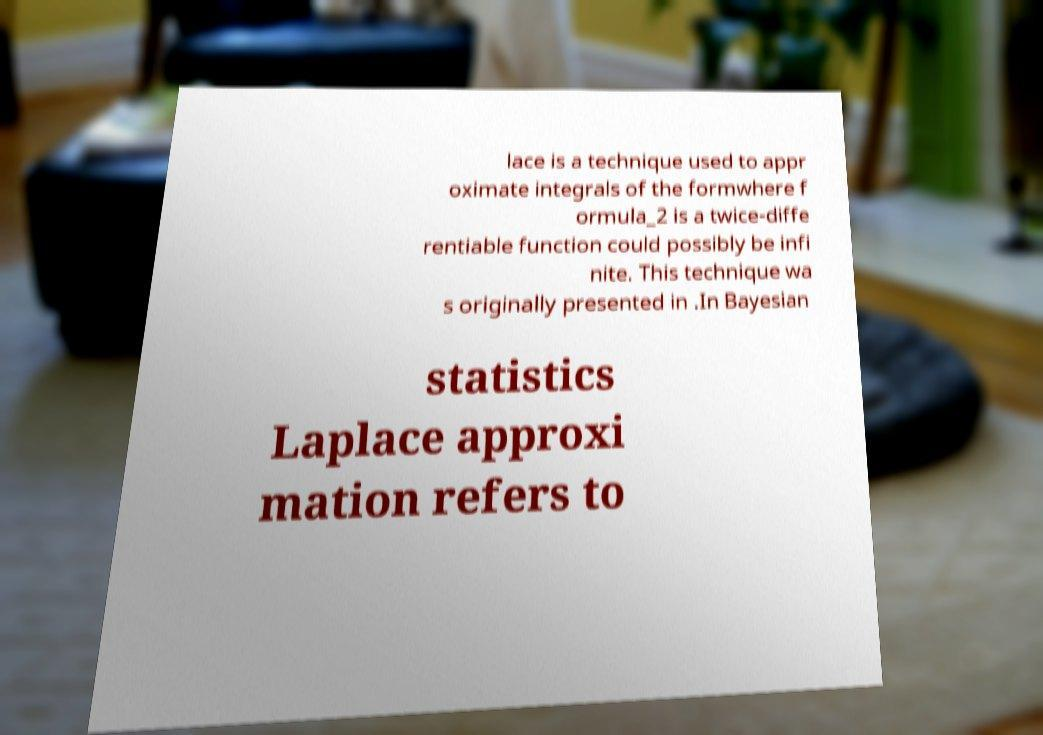Could you extract and type out the text from this image? lace is a technique used to appr oximate integrals of the formwhere f ormula_2 is a twice-diffe rentiable function could possibly be infi nite. This technique wa s originally presented in .In Bayesian statistics Laplace approxi mation refers to 